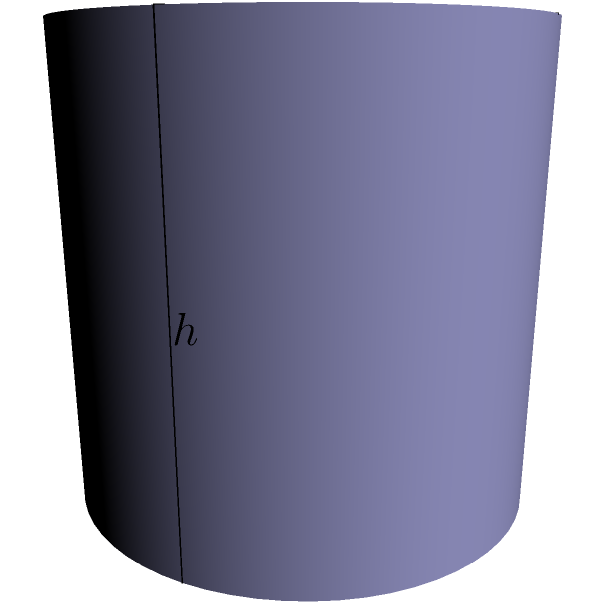You're designing a curved backdrop screen for a theater production. The screen is shaped like a quarter of a cylinder, with a radius of 2 meters and a height of 2 meters. What is the surface area of the curved part of the screen in square meters? Round your answer to two decimal places. To find the surface area of the curved part of the screen, we need to use the formula for the lateral surface area of a cylinder, but adjusted for a quarter of the cylinder:

1) The formula for the lateral surface area of a full cylinder is:
   $A = 2\pi rh$
   where $r$ is the radius and $h$ is the height.

2) Since we only have a quarter of the cylinder, we need to divide this by 4:
   $A = \frac{1}{4} \cdot 2\pi rh = \frac{\pi rh}{2}$

3) We are given:
   $r = 2$ meters
   $h = 2$ meters

4) Let's substitute these values:
   $A = \frac{\pi \cdot 2 \cdot 2}{2} = 2\pi$

5) Calculate:
   $A = 2 \cdot 3.14159... \approx 6.28318...$

6) Rounding to two decimal places:
   $A \approx 6.28$ square meters
Answer: 6.28 sq m 